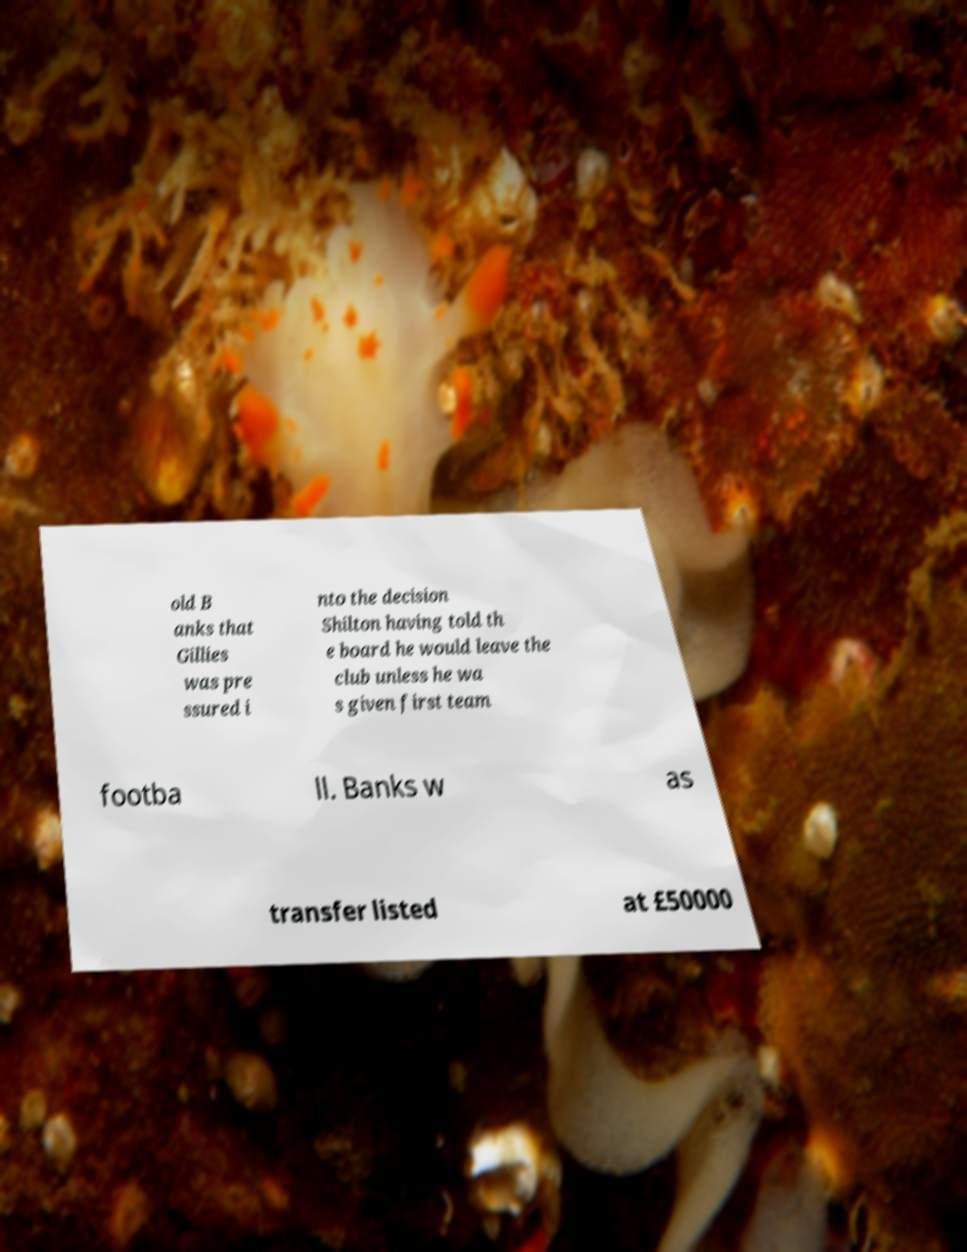Can you accurately transcribe the text from the provided image for me? old B anks that Gillies was pre ssured i nto the decision Shilton having told th e board he would leave the club unless he wa s given first team footba ll. Banks w as transfer listed at £50000 